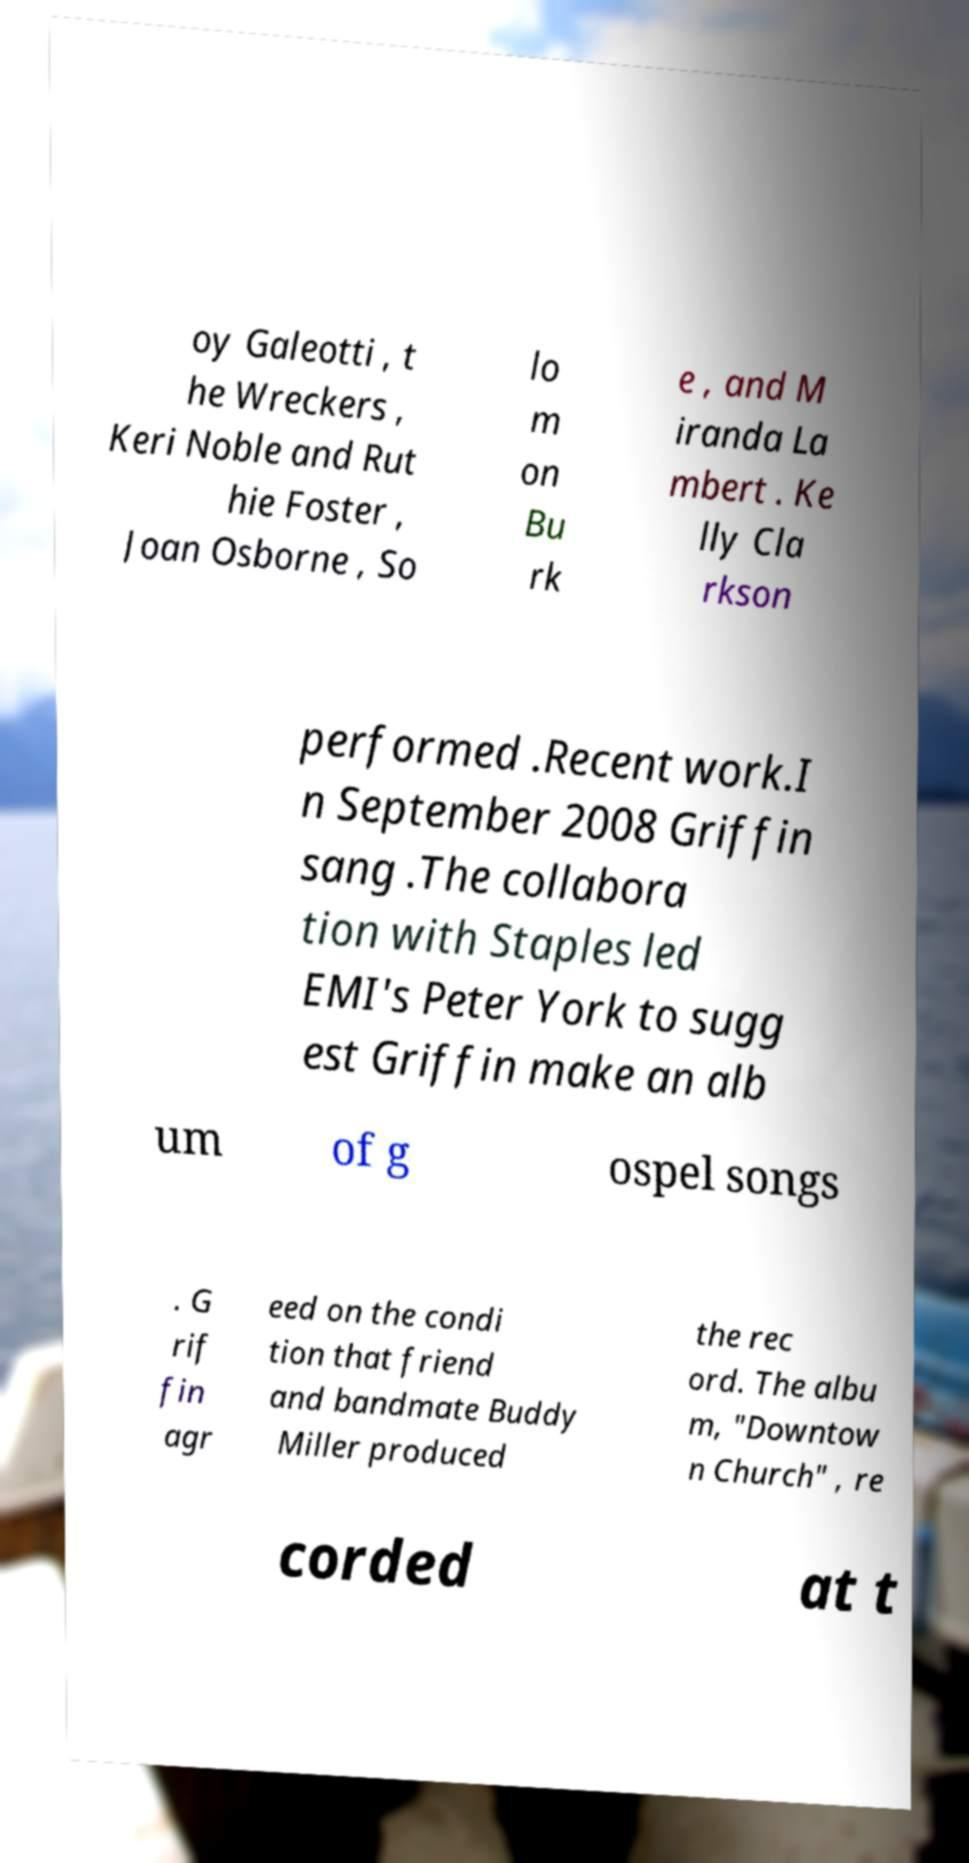Can you read and provide the text displayed in the image?This photo seems to have some interesting text. Can you extract and type it out for me? oy Galeotti , t he Wreckers , Keri Noble and Rut hie Foster , Joan Osborne , So lo m on Bu rk e , and M iranda La mbert . Ke lly Cla rkson performed .Recent work.I n September 2008 Griffin sang .The collabora tion with Staples led EMI's Peter York to sugg est Griffin make an alb um of g ospel songs . G rif fin agr eed on the condi tion that friend and bandmate Buddy Miller produced the rec ord. The albu m, "Downtow n Church" , re corded at t 